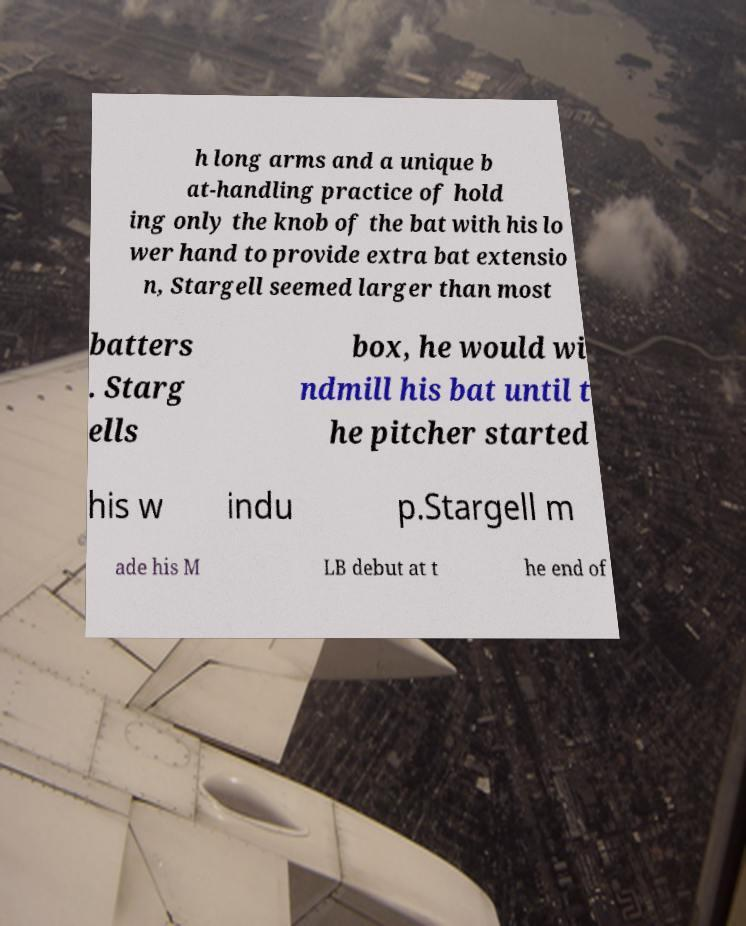What messages or text are displayed in this image? I need them in a readable, typed format. h long arms and a unique b at-handling practice of hold ing only the knob of the bat with his lo wer hand to provide extra bat extensio n, Stargell seemed larger than most batters . Starg ells box, he would wi ndmill his bat until t he pitcher started his w indu p.Stargell m ade his M LB debut at t he end of 